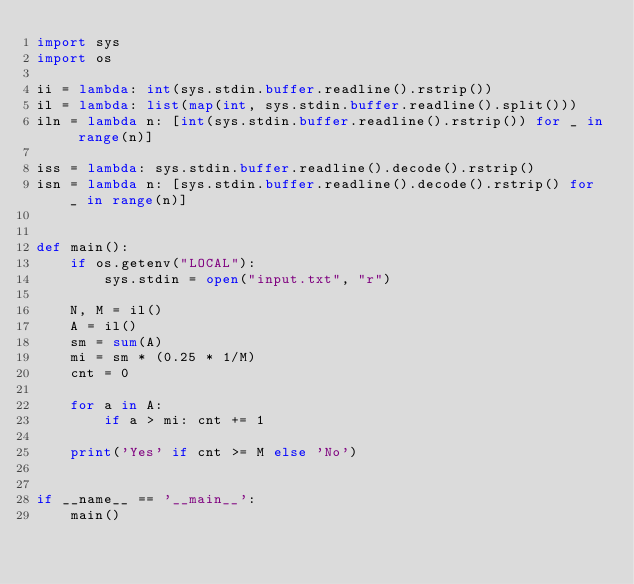<code> <loc_0><loc_0><loc_500><loc_500><_Python_>import sys
import os

ii = lambda: int(sys.stdin.buffer.readline().rstrip())
il = lambda: list(map(int, sys.stdin.buffer.readline().split()))
iln = lambda n: [int(sys.stdin.buffer.readline().rstrip()) for _ in range(n)]

iss = lambda: sys.stdin.buffer.readline().decode().rstrip()
isn = lambda n: [sys.stdin.buffer.readline().decode().rstrip() for _ in range(n)]


def main():
    if os.getenv("LOCAL"):
        sys.stdin = open("input.txt", "r")

    N, M = il()
    A = il()
    sm = sum(A)
    mi = sm * (0.25 * 1/M)
    cnt = 0

    for a in A:
        if a > mi: cnt += 1

    print('Yes' if cnt >= M else 'No')


if __name__ == '__main__':
    main()
</code> 